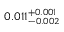<formula> <loc_0><loc_0><loc_500><loc_500>0 . 0 1 1 _ { - 0 . 0 0 2 } ^ { + 0 . 0 0 1 }</formula> 